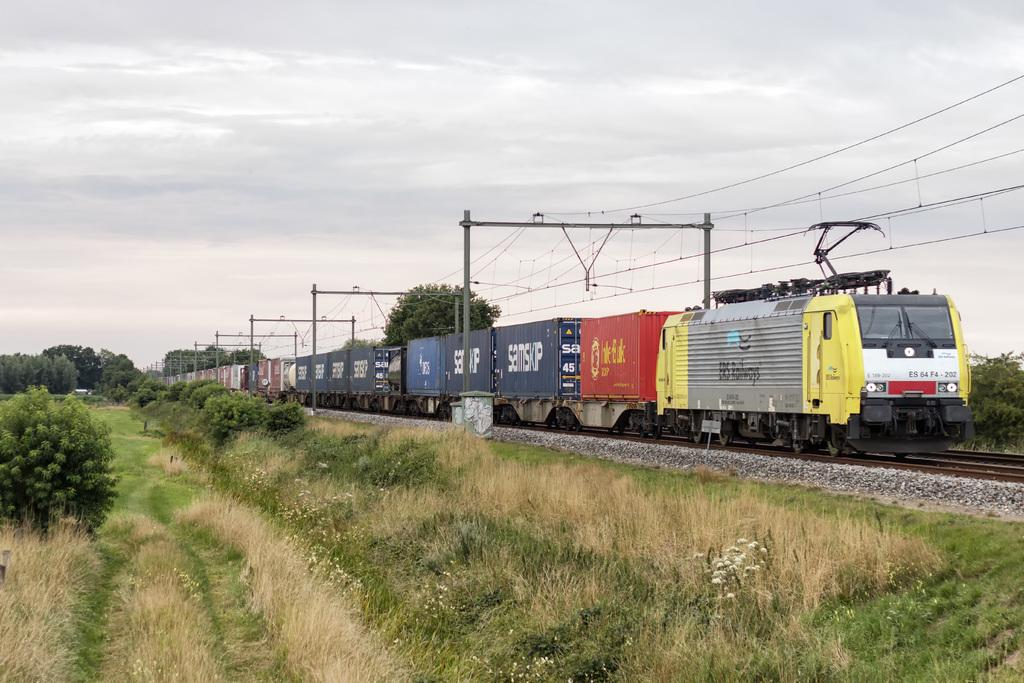<image>
Write a terse but informative summary of the picture. A train is identified by ES 64 F4 on the front car. 